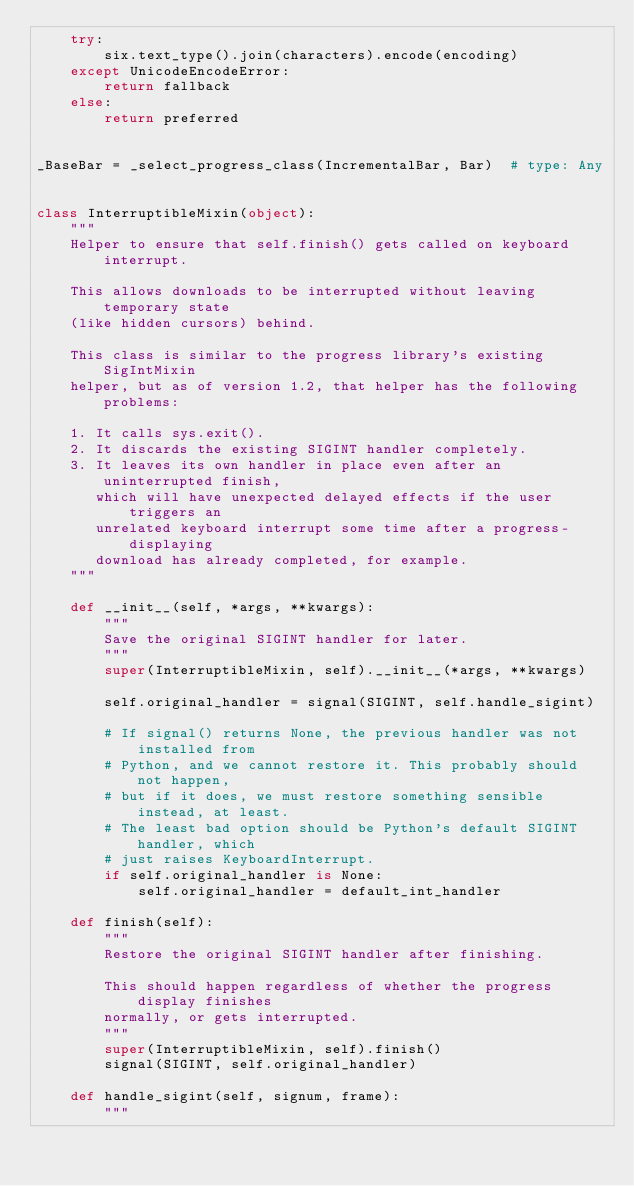Convert code to text. <code><loc_0><loc_0><loc_500><loc_500><_Python_>    try:
        six.text_type().join(characters).encode(encoding)
    except UnicodeEncodeError:
        return fallback
    else:
        return preferred


_BaseBar = _select_progress_class(IncrementalBar, Bar)  # type: Any


class InterruptibleMixin(object):
    """
    Helper to ensure that self.finish() gets called on keyboard interrupt.

    This allows downloads to be interrupted without leaving temporary state
    (like hidden cursors) behind.

    This class is similar to the progress library's existing SigIntMixin
    helper, but as of version 1.2, that helper has the following problems:

    1. It calls sys.exit().
    2. It discards the existing SIGINT handler completely.
    3. It leaves its own handler in place even after an uninterrupted finish,
       which will have unexpected delayed effects if the user triggers an
       unrelated keyboard interrupt some time after a progress-displaying
       download has already completed, for example.
    """

    def __init__(self, *args, **kwargs):
        """
        Save the original SIGINT handler for later.
        """
        super(InterruptibleMixin, self).__init__(*args, **kwargs)

        self.original_handler = signal(SIGINT, self.handle_sigint)

        # If signal() returns None, the previous handler was not installed from
        # Python, and we cannot restore it. This probably should not happen,
        # but if it does, we must restore something sensible instead, at least.
        # The least bad option should be Python's default SIGINT handler, which
        # just raises KeyboardInterrupt.
        if self.original_handler is None:
            self.original_handler = default_int_handler

    def finish(self):
        """
        Restore the original SIGINT handler after finishing.

        This should happen regardless of whether the progress display finishes
        normally, or gets interrupted.
        """
        super(InterruptibleMixin, self).finish()
        signal(SIGINT, self.original_handler)

    def handle_sigint(self, signum, frame):
        """</code> 